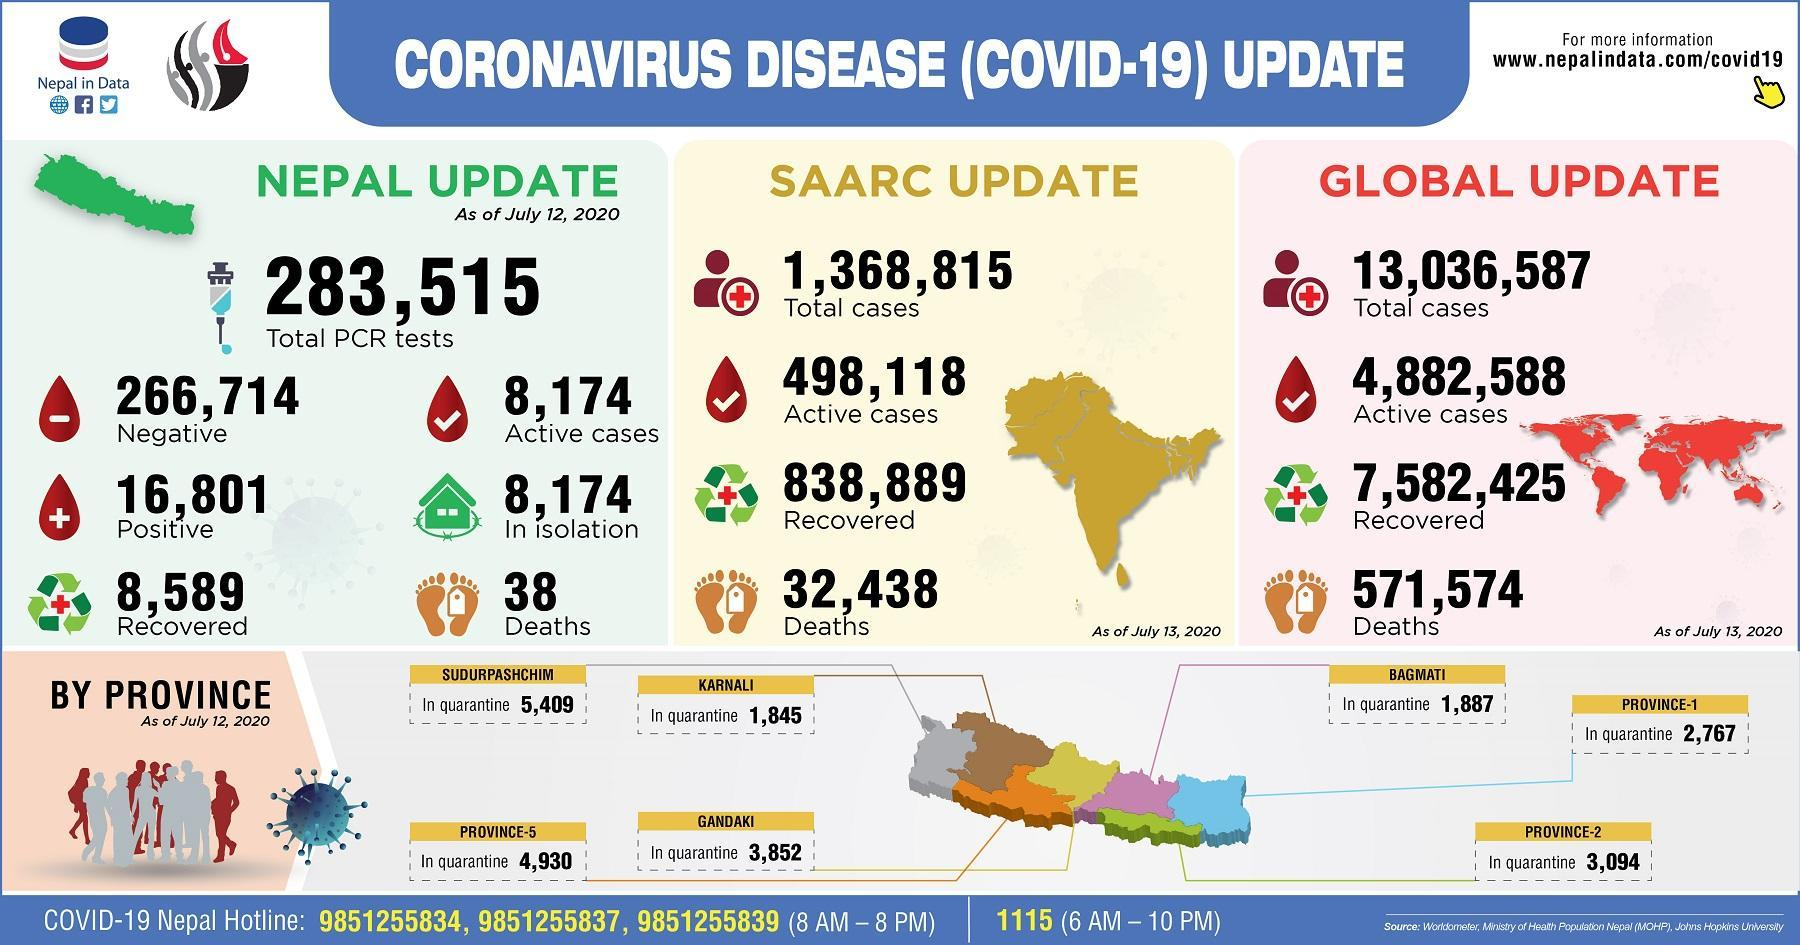How many COVID-19 deaths were reported in Nepal as of July 12, 2020?
Answer the question with a short phrase. 38 How many people were in quarantine in the Karnali province of Nepal as of July 12, 2020? 1,845 How many COVID-19 deaths were reported in the SAARC region as of July 13, 2020? 32,438 How many people were in quarantine in the Bagmati province of Nepal as of July 12, 2020? 1,887 How many people were living in isolation in Nepal as of July 12, 2020? 8,174 How many positive COVID-19 cases were reported in Nepal as of July 12, 2020? 16,801 How many COVID-19 deaths were reported globally as of July 13, 2020? 571,574 What is the number of active COVID-19 cases in the SAARC region as of July 13, 2020? 498,118 What is the number of recovered COVID-19 cases globally as of July 13, 2020? 7,582,425 